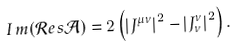Convert formula to latex. <formula><loc_0><loc_0><loc_500><loc_500>I \, m ( \mathcal { R } e s \mathcal { A } ) = 2 \left ( \left | J ^ { \mu \nu } \right | ^ { 2 } - \left | J _ { \nu } ^ { \nu } \right | ^ { 2 } \right ) { . }</formula> 